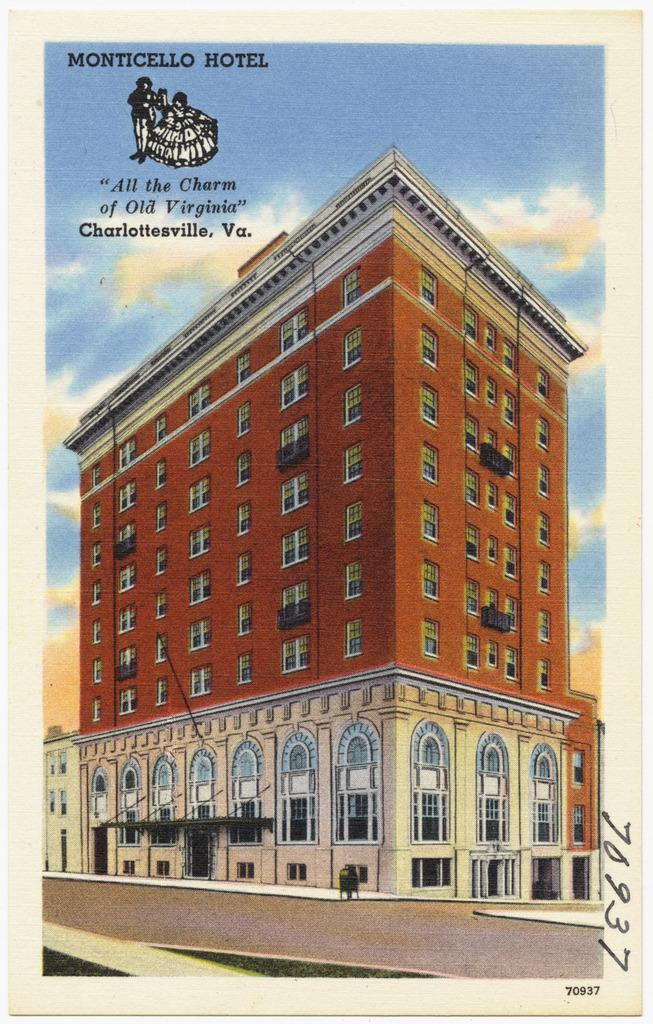What is the main subject of the picture in the image? The main subject of the picture is buildings. What can be seen in the background of the image? The sky with clouds is visible in the image. How is the picture presented? The picture is on a paper. How many sacks are visible in the image? There are no sacks present in the image. What is the end result of the buildings in the image? The image does not depict an end result; it simply shows a picture of buildings. 